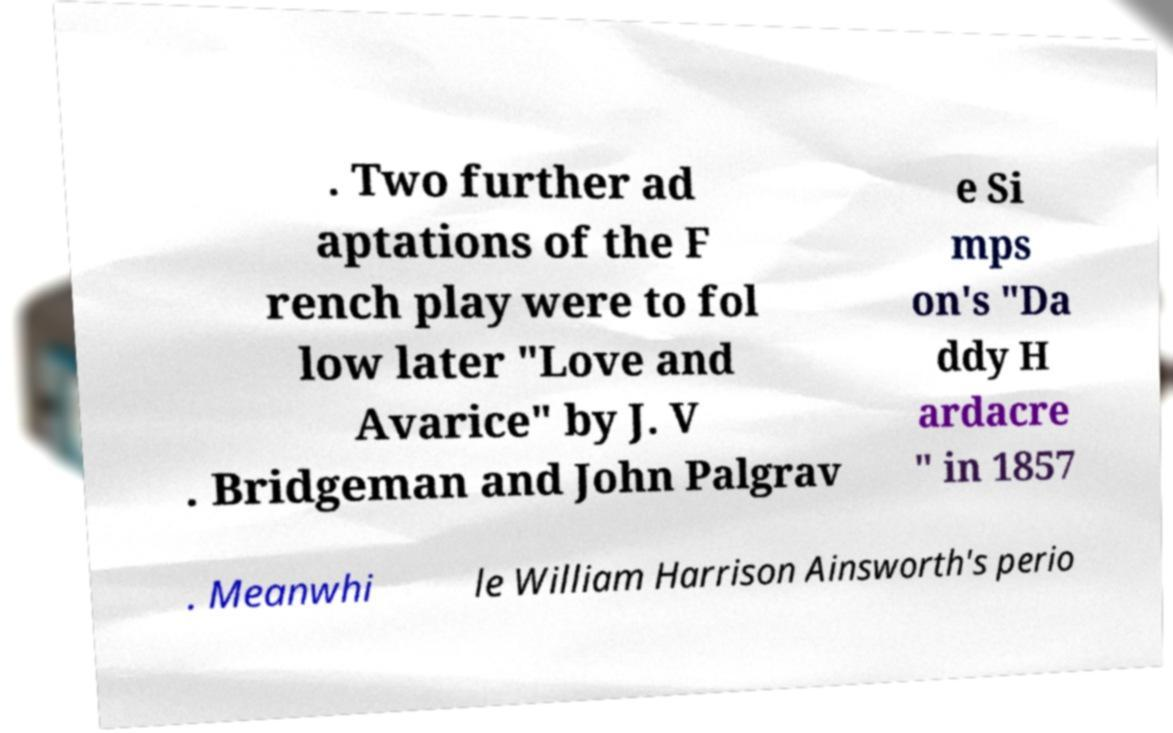Could you assist in decoding the text presented in this image and type it out clearly? . Two further ad aptations of the F rench play were to fol low later "Love and Avarice" by J. V . Bridgeman and John Palgrav e Si mps on's "Da ddy H ardacre " in 1857 . Meanwhi le William Harrison Ainsworth's perio 